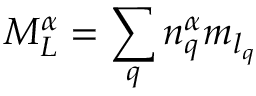Convert formula to latex. <formula><loc_0><loc_0><loc_500><loc_500>{ M } _ { L } ^ { \alpha } = \sum _ { q } { n } _ { q } ^ { \alpha } { m } _ { { l } _ { q } }</formula> 